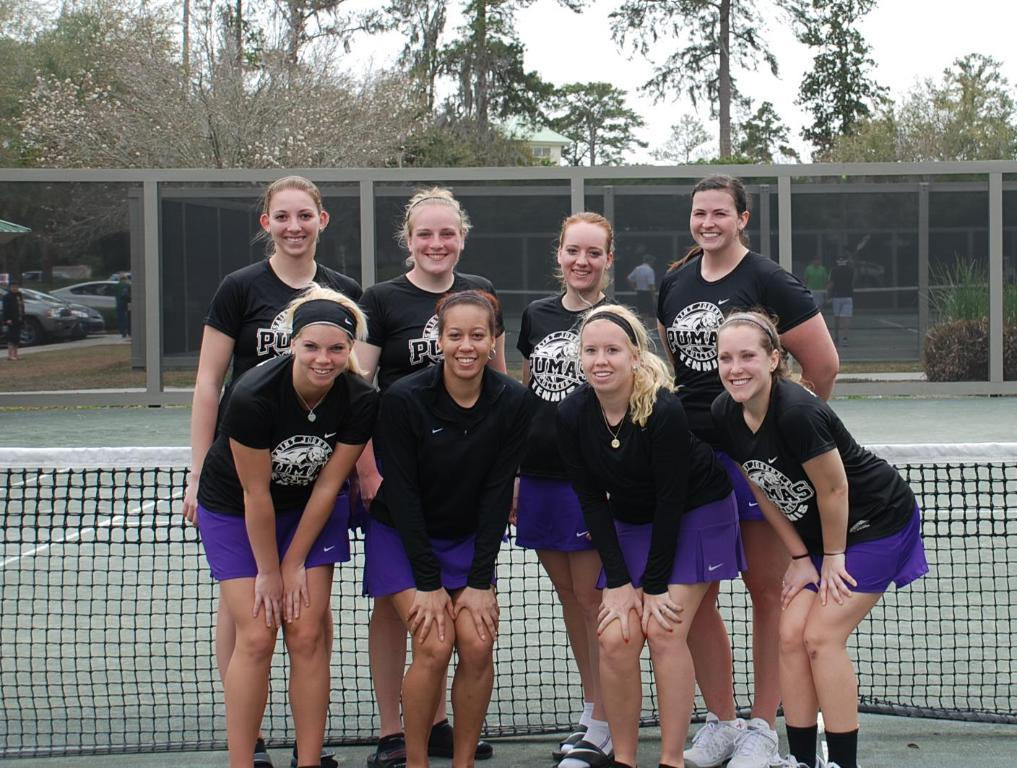Provide a one-sentence caption for the provided image. Eight women with shirts that say Pumas are posing for a photo on a tennis court. 